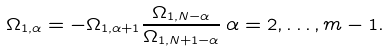Convert formula to latex. <formula><loc_0><loc_0><loc_500><loc_500>\Omega _ { 1 , \alpha } = - \Omega _ { 1 , \alpha + 1 } \frac { \Omega _ { 1 , N - \alpha } } { \Omega _ { 1 , N + 1 - \alpha } } \, \alpha = 2 , \dots , m - 1 .</formula> 